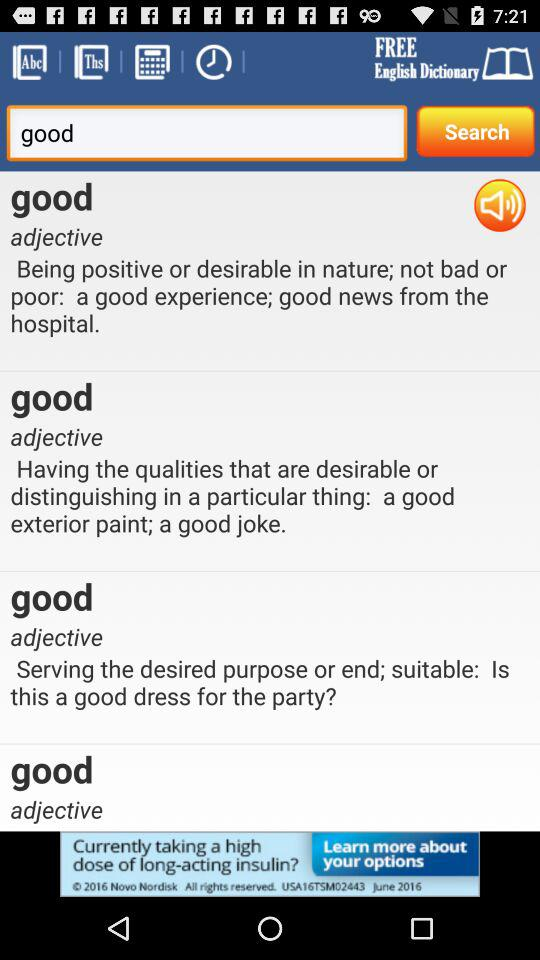Is the app free or paid? The app is free. 